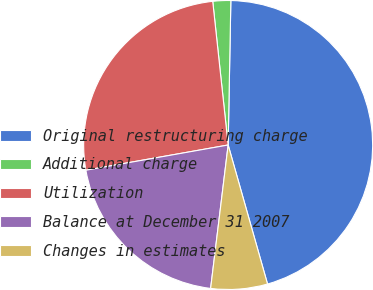Convert chart to OTSL. <chart><loc_0><loc_0><loc_500><loc_500><pie_chart><fcel>Original restructuring charge<fcel>Additional charge<fcel>Utilization<fcel>Balance at December 31 2007<fcel>Changes in estimates<nl><fcel>45.31%<fcel>2.0%<fcel>26.09%<fcel>20.27%<fcel>6.33%<nl></chart> 